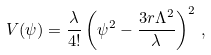Convert formula to latex. <formula><loc_0><loc_0><loc_500><loc_500>V ( \psi ) = { \frac { \lambda } { 4 ! } } \left ( \psi ^ { 2 } - { \frac { 3 r \Lambda ^ { 2 } } { \lambda } } \right ) ^ { 2 } \, ,</formula> 